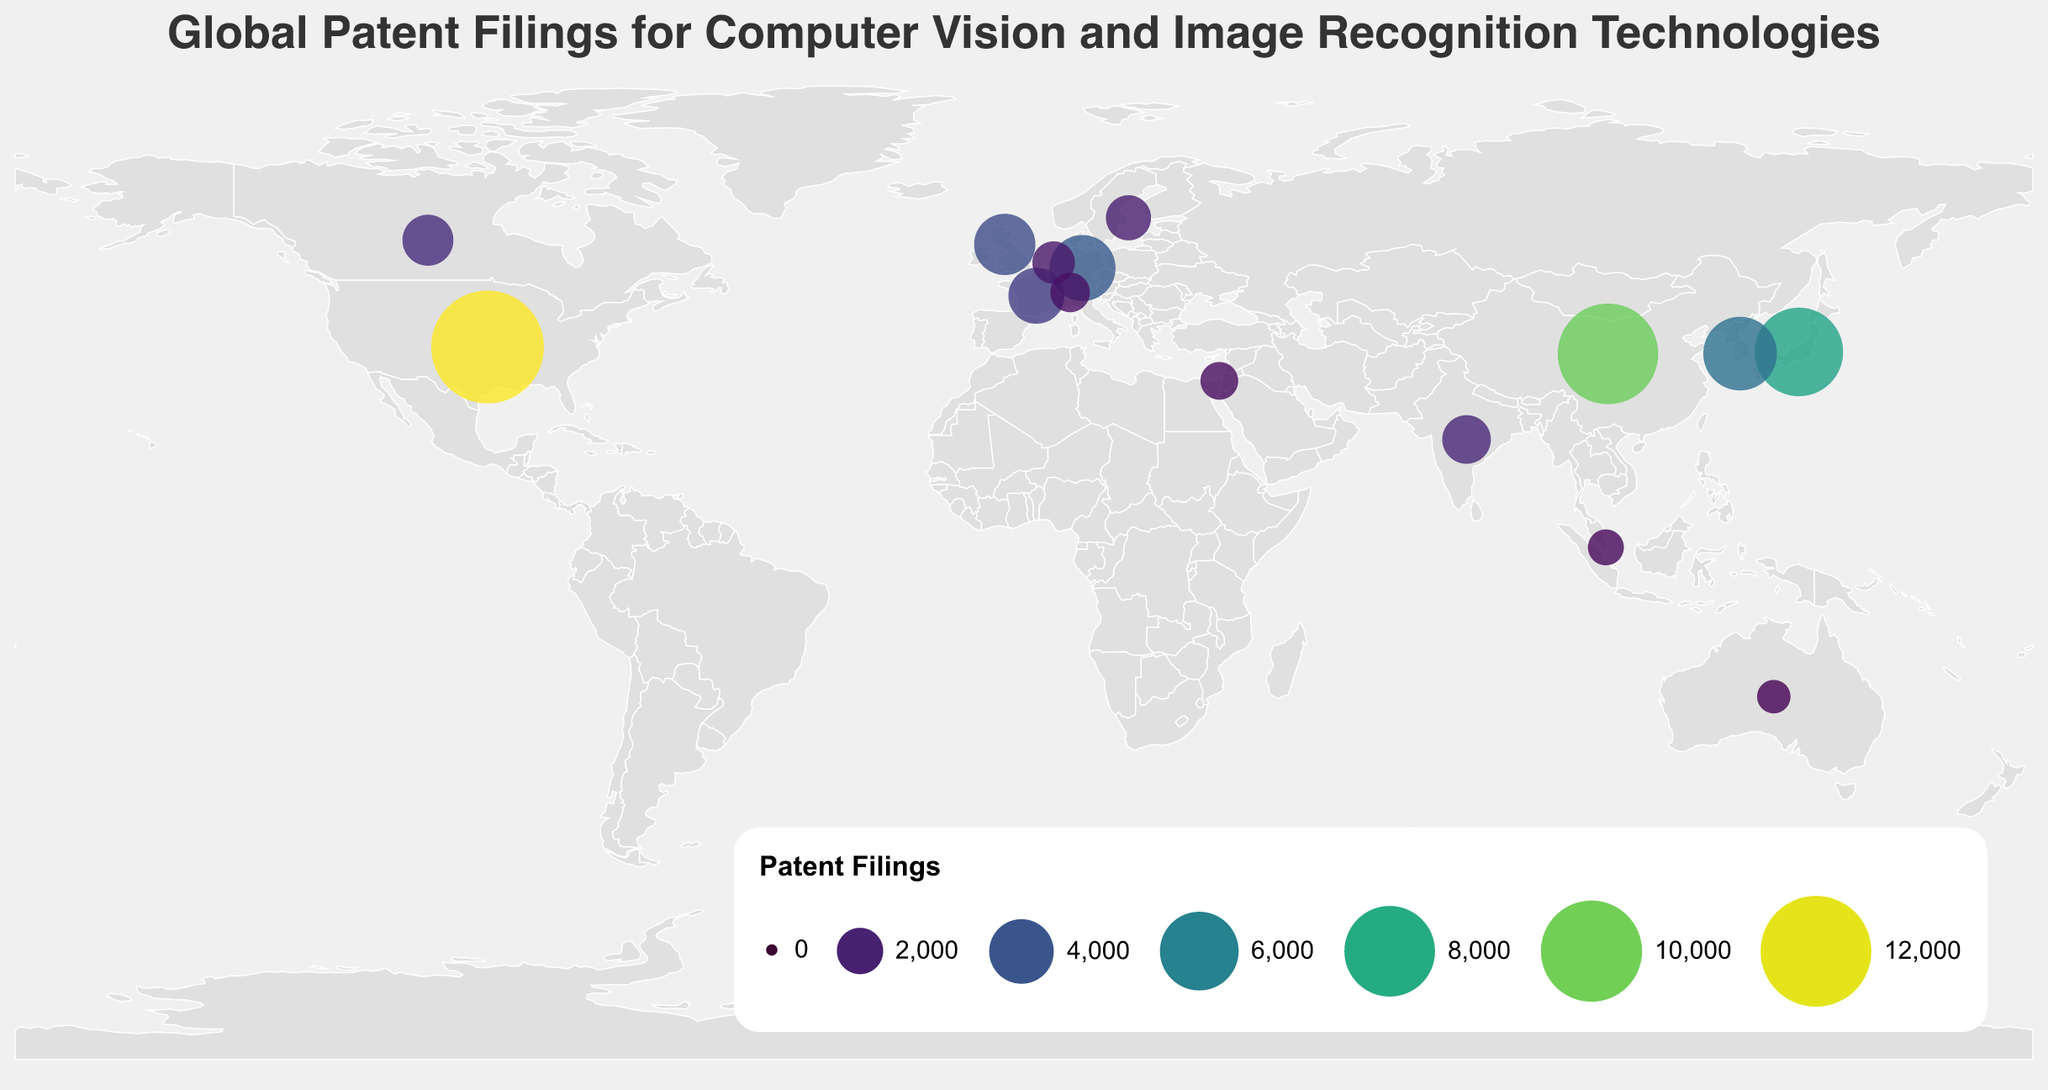What is the country with the highest number of patent filings for computer vision and image recognition technologies? The country with the highest number of patent filings is determined by finding the data point with the largest value in the 'PatentFilings' field. Referring to the figure, the United States has the largest circle and the highest number indicated.
Answer: United States How many patent filings does Germany have? To find the number of patent filings for Germany, look for the data point labeled "Germany" in the figure and read the associated value. The tooltip or circle size can help identify Germany's representation on the map.
Answer: 4180 Which country has more patent filings: Japan or China? Compare the 'PatentFilings' values for Japan and China. According to the figure, China has 9870 filings, whereas Japan has 7630 filings. Since 9870 > 7630, China has more patent filings.
Answer: China What is the sum of patent filings in Canada and Australia? Add the number of patent filings for Canada and Australia. From the data, Canada has 2450 filings and Australia has 980 filings. The sum is 2450 + 980 = 3430.
Answer: 3430 Estimate the total number of patent filings for the top three countries. Add the number of patent filings for the United States (12450), China (9870), and Japan (7630). The total is 12450 + 9870 + 7630 = 29950.
Answer: 29950 Which country has the smallest number of patent filings, and what is that number? Identify the data point with the smallest value in the 'PatentFilings' field. According to the figure, it is Australia with 980 patent filings.
Answer: Australia, 980 What is the average number of patent filings for the countries with over 5000 filings? First, identify the countries with over 5000 filings: United States (12450), China (9870), Japan (7630), and South Korea (5240). Then, find the average by adding these numbers and dividing by the number of countries: (12450 + 9870 + 7630 + 5240) / 4 = 88,40 / 4 = 8467.5
Answer: 8467.5 How does the number of patent filings in India compare to those in France? Compare the 'PatentFilings' values for India and France. India has 2210 filings, while France has 2980. Since 2210 < 2980, India has fewer filings than France.
Answer: India has fewer filings What color represents the highest number of patent filings, and which country does it associate with? The color scheme used in the figure is 'viridis', where darker shades typically represent higher values. The darkest circle, representing the highest filing count, is associated with the United States.
Answer: Darkest color, United States Which countries fall within the middle range (2000 to 5000) of patent filings? Identify the countries with 'PatentFilings' values between 2000 and 5000. According to the data, these countries are South Korea, Germany, United Kingdom, France, Canada, and India.
Answer: South Korea, Germany, United Kingdom, France, Canada, and India 